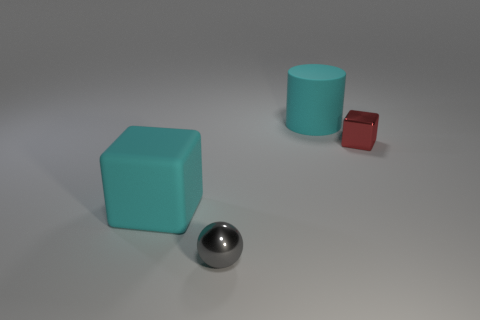There is a cyan thing that is the same material as the large cyan cylinder; what shape is it?
Give a very brief answer. Cube. Are there any other things that have the same shape as the gray metallic thing?
Offer a terse response. No. What color is the thing that is both on the left side of the rubber cylinder and behind the small gray metal ball?
Your answer should be compact. Cyan. What number of cubes are large rubber things or small red metal objects?
Give a very brief answer. 2. What number of red metal blocks are the same size as the cyan cylinder?
Make the answer very short. 0. What number of large cyan matte cubes are behind the rubber thing that is left of the gray object?
Provide a short and direct response. 0. What size is the object that is behind the tiny gray sphere and in front of the metallic block?
Provide a succinct answer. Large. Is the number of large rubber cubes greater than the number of cyan metallic things?
Offer a terse response. Yes. Is there a large object that has the same color as the big cylinder?
Provide a succinct answer. Yes. There is a cyan matte thing in front of the red metal block; is it the same size as the tiny metallic block?
Make the answer very short. No. 